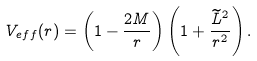Convert formula to latex. <formula><loc_0><loc_0><loc_500><loc_500>V _ { e f f } ( r ) = \left ( 1 - \frac { 2 M } { r } \right ) \left ( 1 + \frac { \widetilde { L } ^ { 2 } } { r ^ { 2 } } \right ) .</formula> 